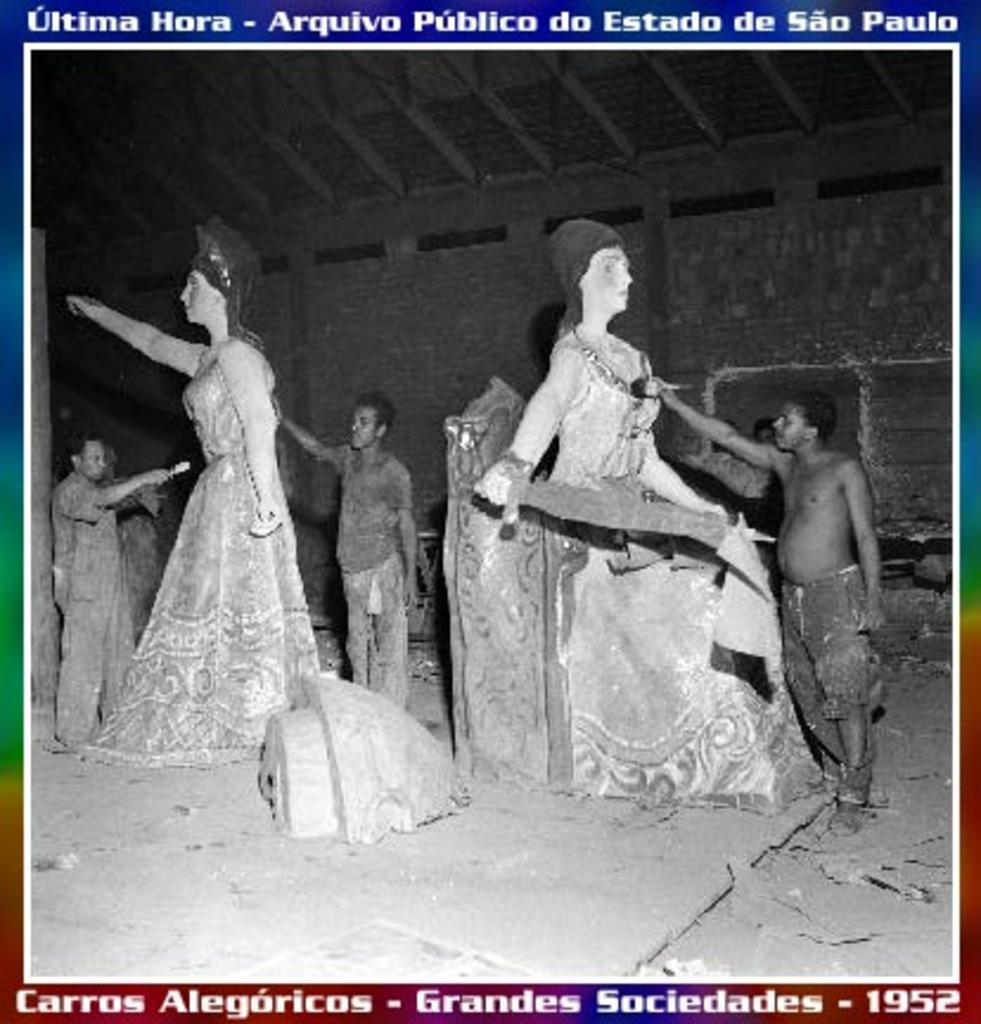<image>
Render a clear and concise summary of the photo. Men work on statues for an event held in Sao Paulo in 1952. 